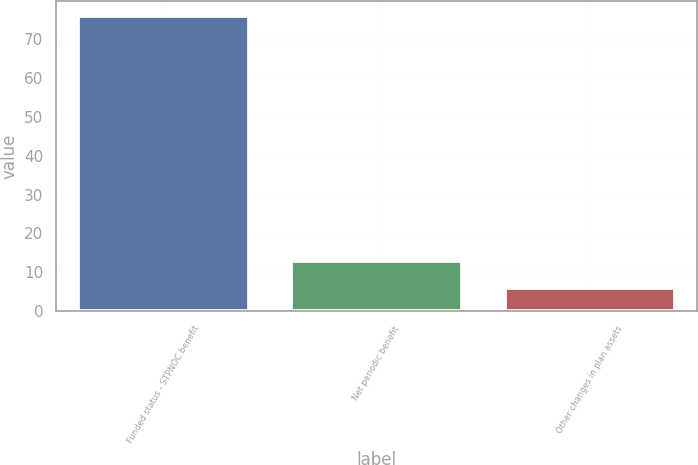<chart> <loc_0><loc_0><loc_500><loc_500><bar_chart><fcel>Funded status - STPNOC benefit<fcel>Net periodic benefit<fcel>Other changes in plan assets<nl><fcel>76<fcel>13<fcel>6<nl></chart> 